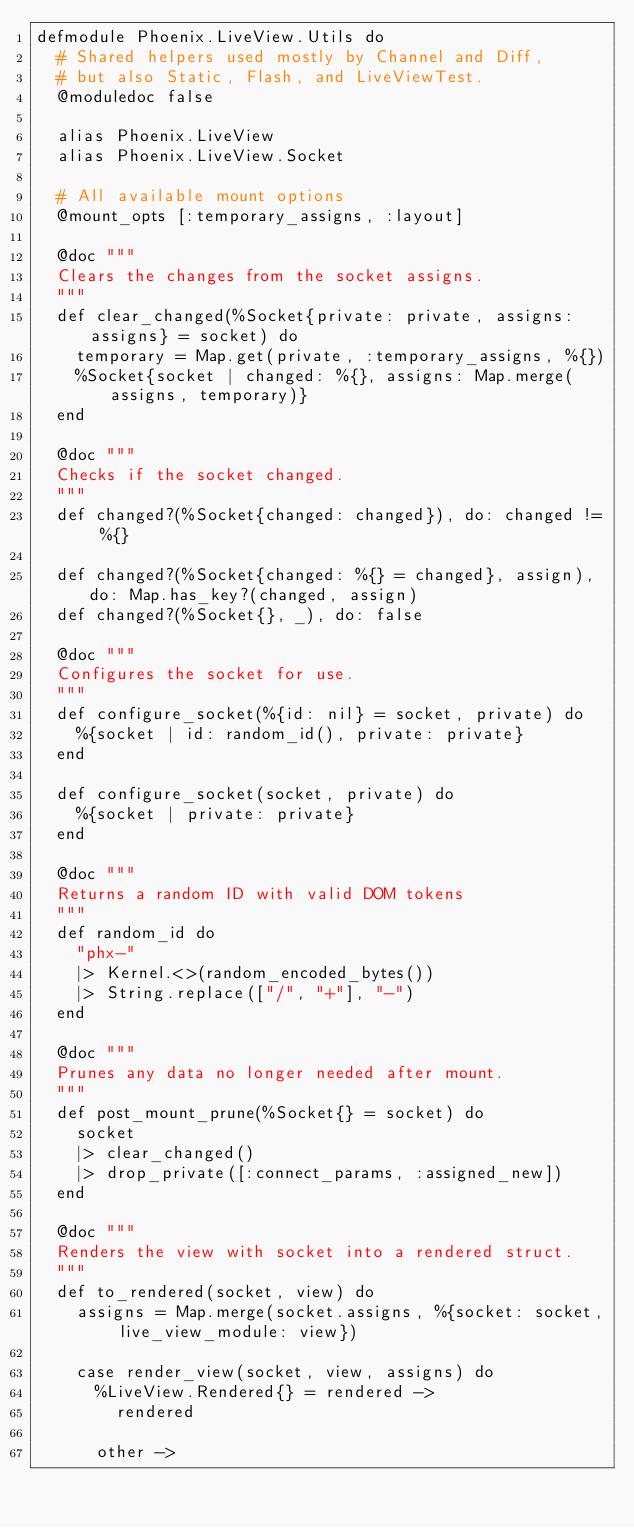<code> <loc_0><loc_0><loc_500><loc_500><_Elixir_>defmodule Phoenix.LiveView.Utils do
  # Shared helpers used mostly by Channel and Diff,
  # but also Static, Flash, and LiveViewTest.
  @moduledoc false

  alias Phoenix.LiveView
  alias Phoenix.LiveView.Socket

  # All available mount options
  @mount_opts [:temporary_assigns, :layout]

  @doc """
  Clears the changes from the socket assigns.
  """
  def clear_changed(%Socket{private: private, assigns: assigns} = socket) do
    temporary = Map.get(private, :temporary_assigns, %{})
    %Socket{socket | changed: %{}, assigns: Map.merge(assigns, temporary)}
  end

  @doc """
  Checks if the socket changed.
  """
  def changed?(%Socket{changed: changed}), do: changed != %{}

  def changed?(%Socket{changed: %{} = changed}, assign), do: Map.has_key?(changed, assign)
  def changed?(%Socket{}, _), do: false

  @doc """
  Configures the socket for use.
  """
  def configure_socket(%{id: nil} = socket, private) do
    %{socket | id: random_id(), private: private}
  end

  def configure_socket(socket, private) do
    %{socket | private: private}
  end

  @doc """
  Returns a random ID with valid DOM tokens
  """
  def random_id do
    "phx-"
    |> Kernel.<>(random_encoded_bytes())
    |> String.replace(["/", "+"], "-")
  end

  @doc """
  Prunes any data no longer needed after mount.
  """
  def post_mount_prune(%Socket{} = socket) do
    socket
    |> clear_changed()
    |> drop_private([:connect_params, :assigned_new])
  end

  @doc """
  Renders the view with socket into a rendered struct.
  """
  def to_rendered(socket, view) do
    assigns = Map.merge(socket.assigns, %{socket: socket, live_view_module: view})

    case render_view(socket, view, assigns) do
      %LiveView.Rendered{} = rendered ->
        rendered

      other -></code> 